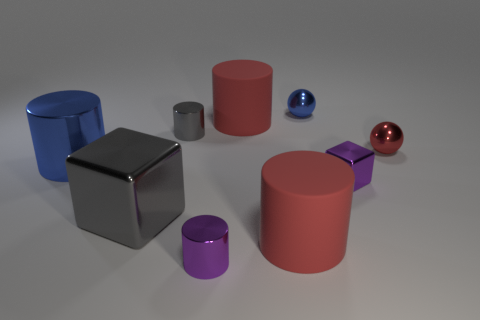There is a metallic cylinder behind the large blue cylinder; is its color the same as the large cube?
Your response must be concise. Yes. What color is the large shiny object that is the same shape as the small gray thing?
Keep it short and to the point. Blue. There is a thing that is the same color as the tiny cube; what shape is it?
Keep it short and to the point. Cylinder. Are there more tiny blue metal things left of the large gray thing than small cylinders behind the small red metal sphere?
Provide a succinct answer. No. What is the size of the thing that is the same color as the small block?
Offer a terse response. Small. How many other things are the same size as the blue cylinder?
Keep it short and to the point. 3. Are the large red cylinder that is behind the blue metallic cylinder and the gray cylinder made of the same material?
Keep it short and to the point. No. What number of other things are the same shape as the large blue thing?
Offer a very short reply. 4. Is the shape of the blue shiny thing left of the blue metal ball the same as the small metal thing that is left of the tiny purple metallic cylinder?
Give a very brief answer. Yes. Are there an equal number of shiny spheres that are to the left of the blue cylinder and blue shiny cylinders in front of the large block?
Keep it short and to the point. Yes. 